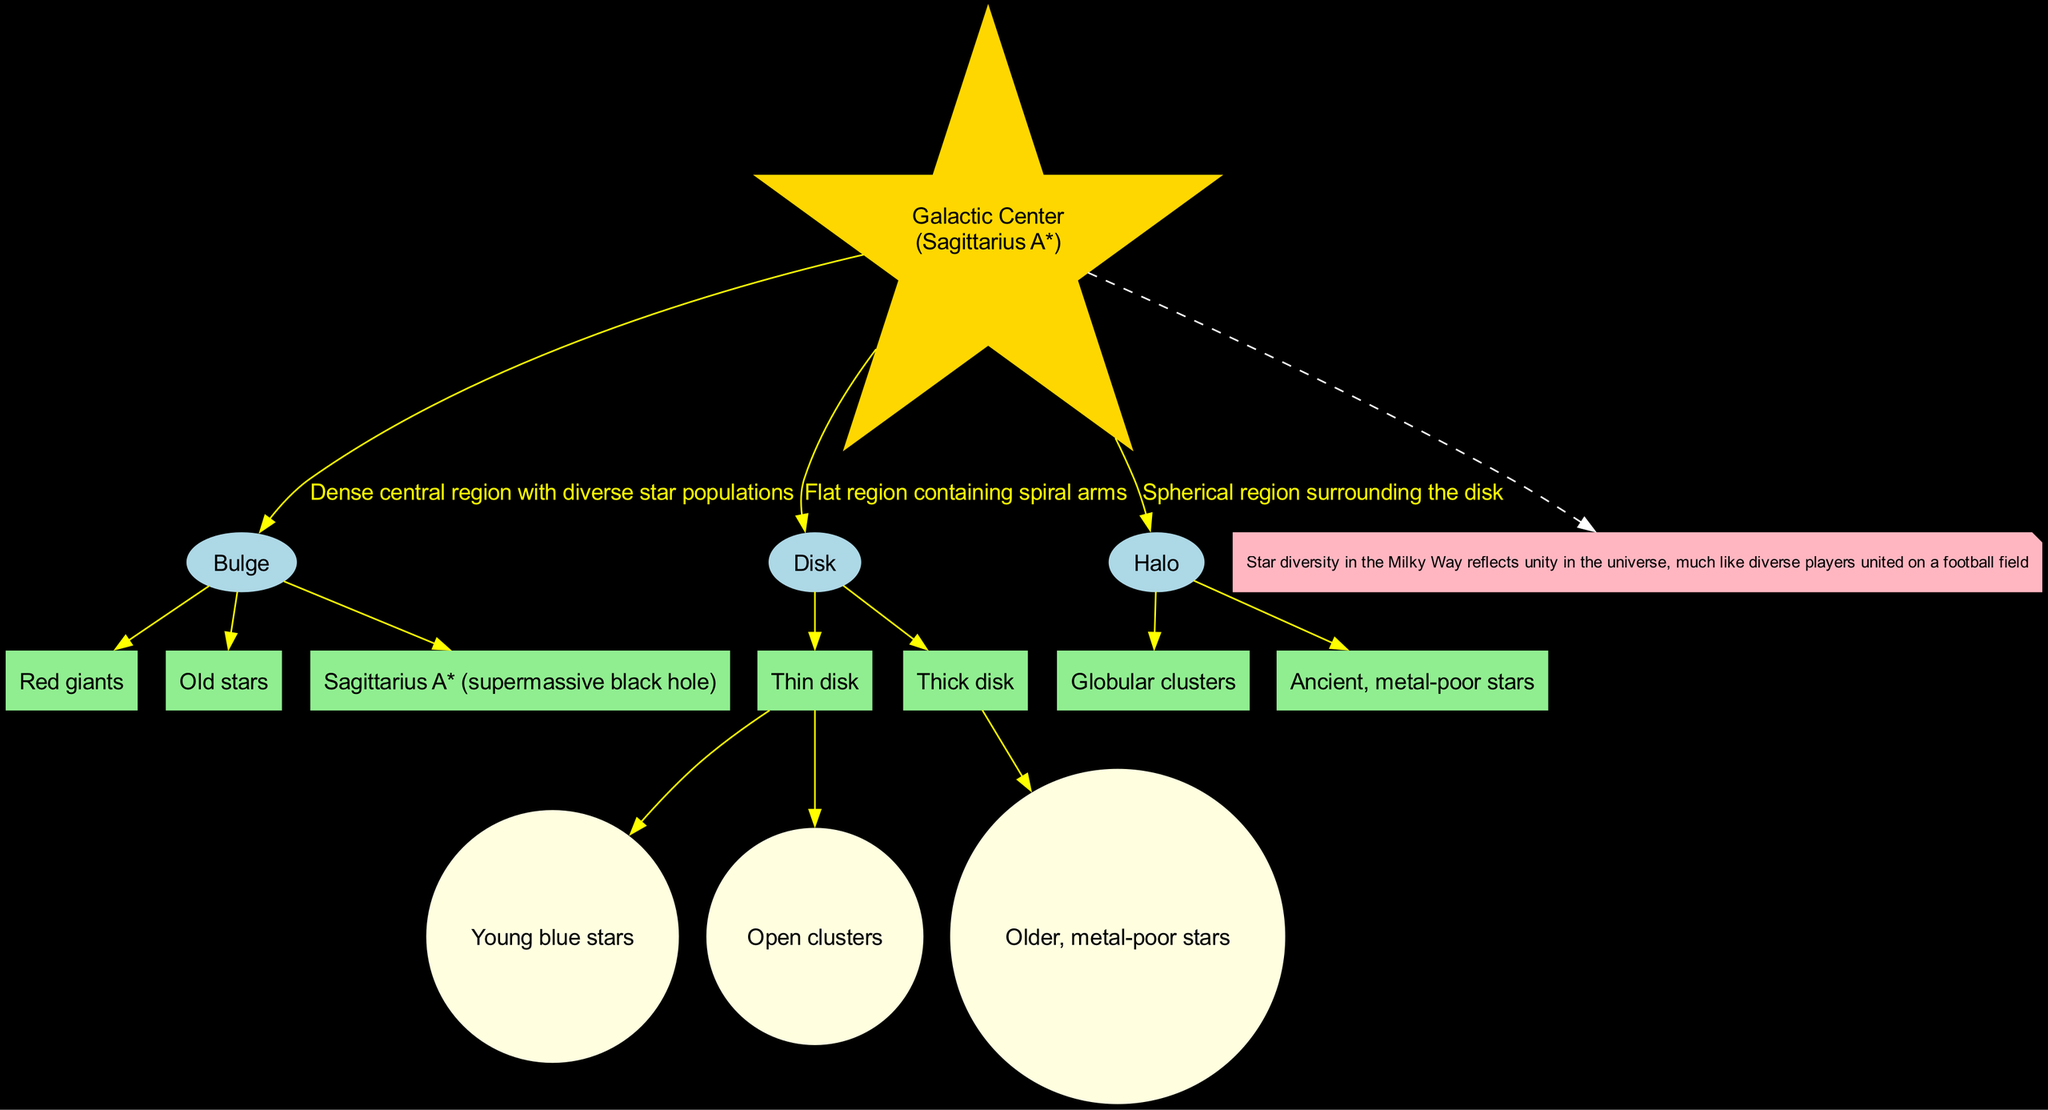What is the name of the central region of the Milky Way? The diagram identifies the "Galactic Center" as the central region, which is directly labeled in the diagram.
Answer: Galactic Center How many main components does the diagram show? The diagram features three main components: Bulge, Disk, and Halo, which are listed under the components section.
Answer: 3 What type of stars are found in the Thin Disk? The Thin Disk is labeled to contain "Young blue stars" and "Open clusters," which are specifically mentioned as part of its description in the diagram.
Answer: Young blue stars, Open clusters Which component contains Globular clusters? The Halo component is explicitly stated to contain Globular clusters in the diagram, which links directly to the description provided.
Answer: Halo What is a characteristic of stars in the Thick Disk? The Thick Disk is described as containing "Older, metal-poor stars," indicating its specific type of star population, which can be found in the component's sub-attributes.
Answer: Older, metal-poor stars How does the diagram illustrate the diversity of stars in the Milky Way? The note at the bottom of the diagram explains that star diversity reflects unity in the universe and parallels the unity among diverse players on a football field, tying together the visual structure with a social message.
Answer: Unity in the universe Name the supermassive black hole located at the Galactic Center. The supermassive black hole is explicitly named "Sagittarius A*" in the description of the Bulge component, which indicates its significance in the central region.
Answer: Sagittarius A* What color represents the edges connecting components in the diagram? The edges connecting the components in the diagram are colored yellow, as indicated by the edge attribute specified in the diagram setup.
Answer: Yellow How many subcomponents are listed under the Disk component? The Disk component has two subcomponents: Thin disk and Thick disk, which can be counted explicitly as they are distinguished within the component's structure.
Answer: 2 